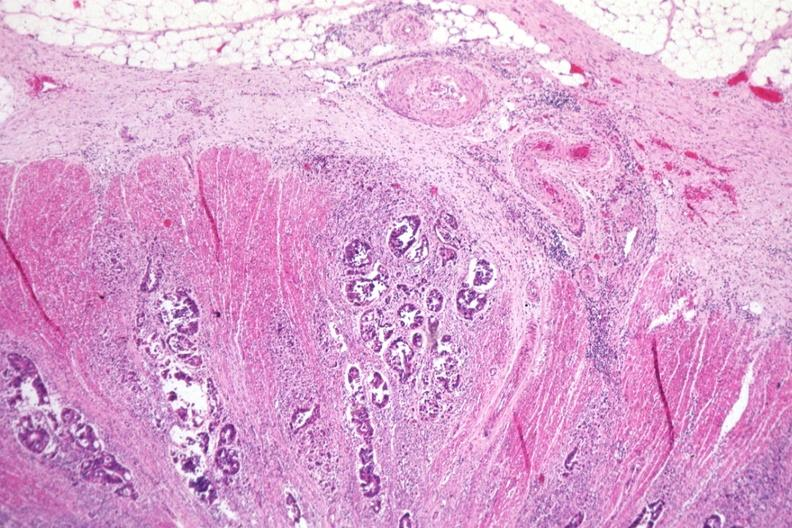does this image show excellent photo typical adenocarcinoma extending through muscularis to serosa?
Answer the question using a single word or phrase. Yes 